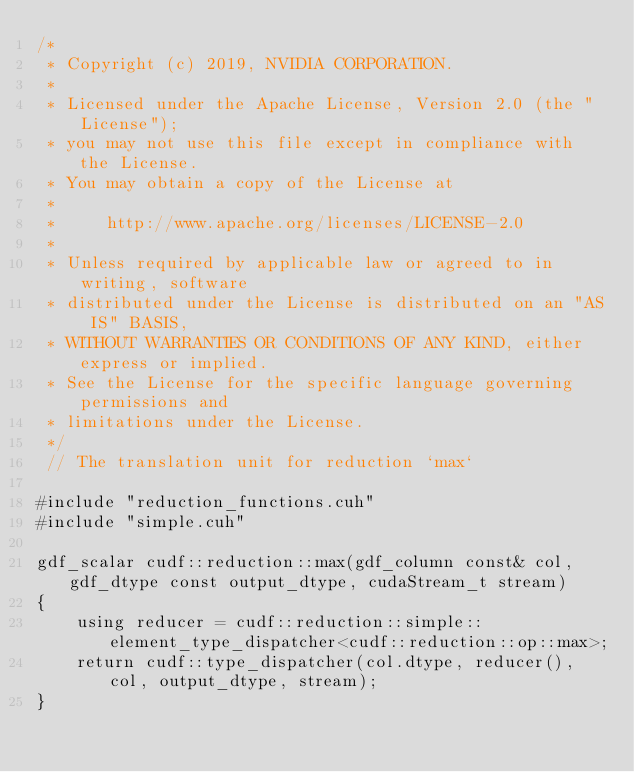Convert code to text. <code><loc_0><loc_0><loc_500><loc_500><_Cuda_>/*
 * Copyright (c) 2019, NVIDIA CORPORATION.
 *
 * Licensed under the Apache License, Version 2.0 (the "License");
 * you may not use this file except in compliance with the License.
 * You may obtain a copy of the License at
 *
 *     http://www.apache.org/licenses/LICENSE-2.0
 *
 * Unless required by applicable law or agreed to in writing, software
 * distributed under the License is distributed on an "AS IS" BASIS,
 * WITHOUT WARRANTIES OR CONDITIONS OF ANY KIND, either express or implied.
 * See the License for the specific language governing permissions and
 * limitations under the License.
 */
 // The translation unit for reduction `max`

#include "reduction_functions.cuh"
#include "simple.cuh"

gdf_scalar cudf::reduction::max(gdf_column const& col, gdf_dtype const output_dtype, cudaStream_t stream)
{
    using reducer = cudf::reduction::simple::element_type_dispatcher<cudf::reduction::op::max>;
    return cudf::type_dispatcher(col.dtype, reducer(), col, output_dtype, stream);
}


</code> 